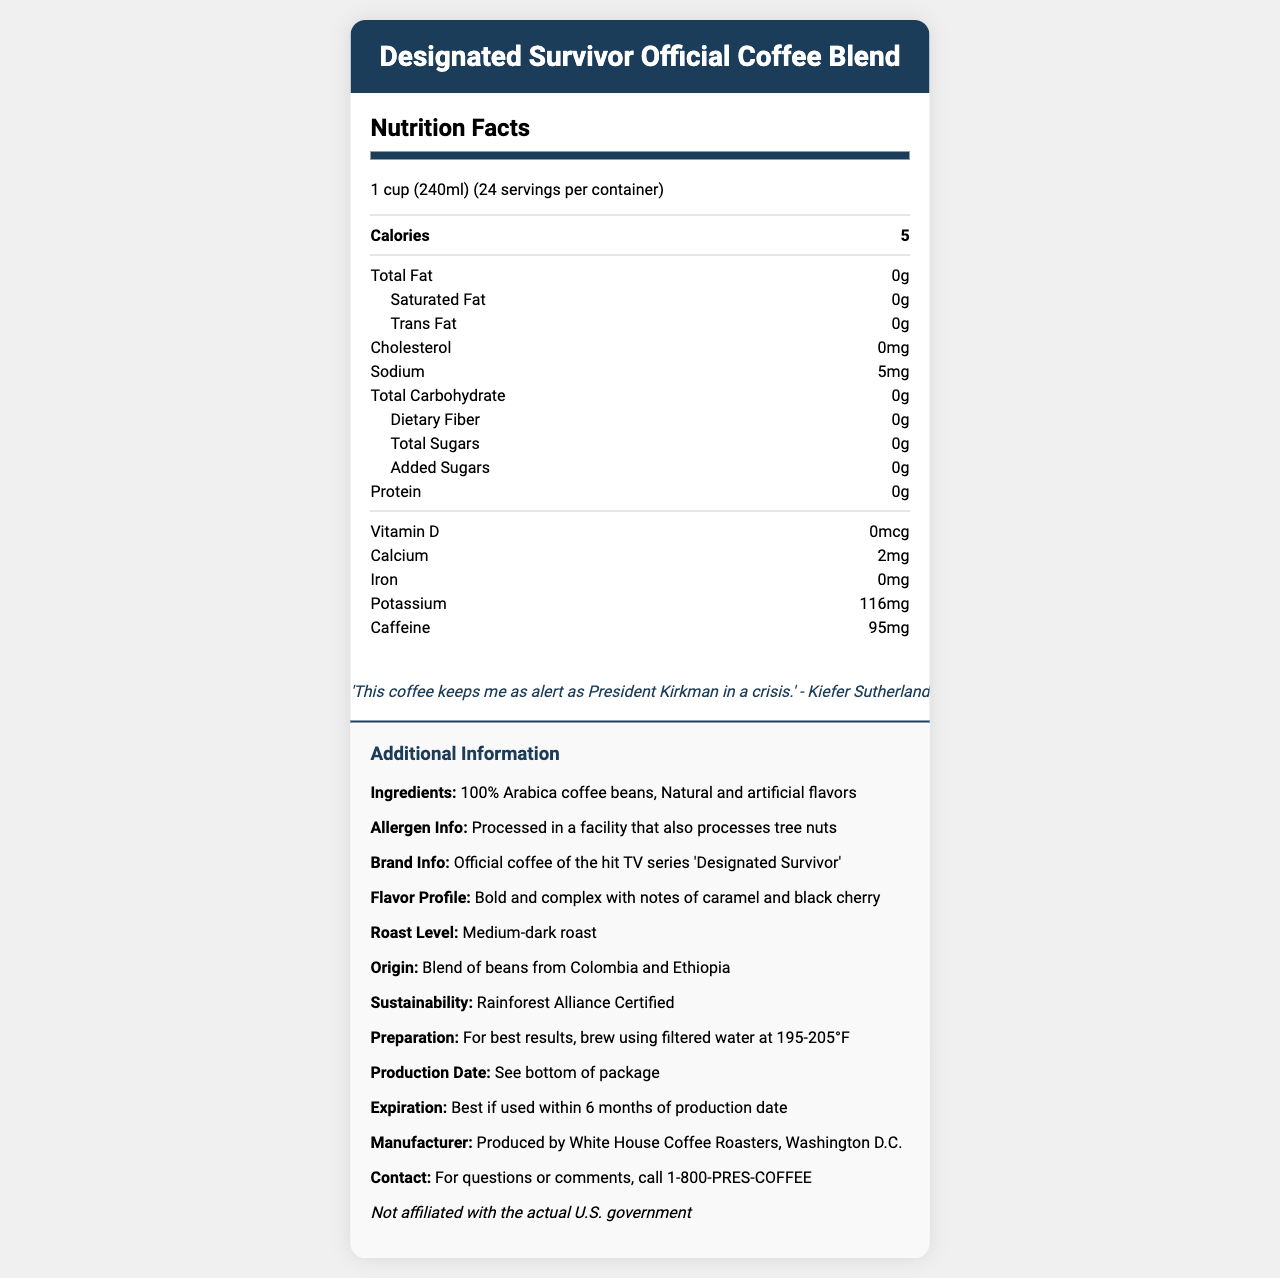how many calories are in one serving of the Designated Survivor Official Coffee Blend? The document lists that there are 5 calories per serving.
Answer: 5 what is the sodium content per serving? The Nutrition Facts section states that one serving contains 5mg of sodium.
Answer: 5mg what are the two countries of origin for the coffee beans? The additional information section mentions the origin as a blend of beans from Colombia and Ethiopia.
Answer: Colombia and Ethiopia does the coffee contain any added sugars? The Nutrition Facts specifies that the amount of added sugars is 0g.
Answer: No what is the serving size for this coffee? The document states that one serving size is 1 cup, which is 240ml.
Answer: 1 cup (240ml) what is the caffeine content per serving? The Nutrition Facts section specifies that one serving contains 95mg of caffeine.
Answer: 95mg how many servings are in one container? A. 12 B. 24 C. 36 The document indicates that there are 24 servings per container.
Answer: B. 24 which of the following vitamins and minerals is most abundant in the coffee blend? I. Vitamin D II. Calcium III. Potassium IV. Iron The Nutrition Facts section shows Potassium content as 116mg, whereas Vitamin D, Calcium, and Iron contents are very minimal or zero.
Answer: III. Potassium is the Designated Survivor Official Coffee Blend affiliated with the actual U.S. government? The disclaimer at the end of the document states that it is not affiliated with the actual U.S. government.
Answer: No summarize the main features of the Designated Survivor Official Coffee Blend. The summary encapsulates the key details, such as nutritional content, origin, flavor profile, sustainability, and brand information mentioned in the document.
Answer: The Designated Survivor Official Coffee Blend is a bold and complex medium-dark roast coffee with notes of caramel and black cherry, originating from a blend of beans from Colombia and Ethiopia. It is low in calories, sodium, and contains no sugars, fat, or cholesterol. The coffee is Rainforest Alliance Certified, contains 95mg of caffeine per serving, and is endorsed by Kiefer Sutherland. The product includes allergen information and preparation instructions. what is the contact number for questions or comments about this product? The contact information section lists the number 1-800-PRES-COFFEE.
Answer: 1-800-PRES-COFFEE describe the flavor profile of the coffee blend. The additional information section details the flavor profile as bold and complex with notes of caramel and black cherry.
Answer: Bold and complex with notes of caramel and black cherry is there any cholesterol in the coffee blend? The Nutrition Facts indicate that the amount of cholesterol is 0mg.
Answer: No can we determine the production date of the coffee from the document? The document mentions that the production date is on the bottom of the package, so it’s not visible in the document provided.
Answer: No, we cannot determine the exact production date as we are directed to see the bottom of the package for that information. who is the manufacturer of the Designated Survivor Official Coffee Blend? The manufacturer information section states that the coffee is produced by White House Coffee Roasters in Washington D.C.
Answer: White House Coffee Roasters, Washington D.C. 